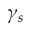Convert formula to latex. <formula><loc_0><loc_0><loc_500><loc_500>\gamma _ { s }</formula> 